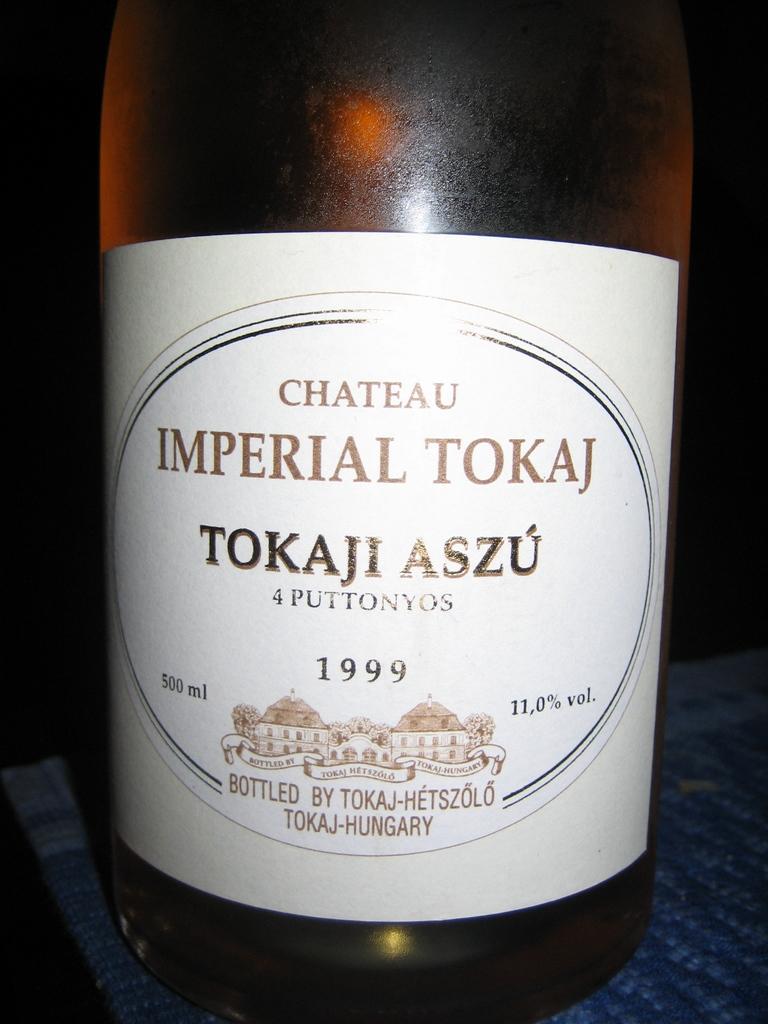What year was this wine made?
Ensure brevity in your answer.  1999. Who was this wine bottled by?
Provide a short and direct response. Tokaji aszu. 